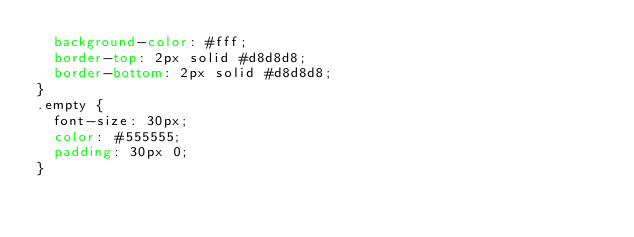Convert code to text. <code><loc_0><loc_0><loc_500><loc_500><_CSS_>  background-color: #fff;
  border-top: 2px solid #d8d8d8;
  border-bottom: 2px solid #d8d8d8;
}
.empty {
  font-size: 30px;
  color: #555555;
  padding: 30px 0;
}
</code> 